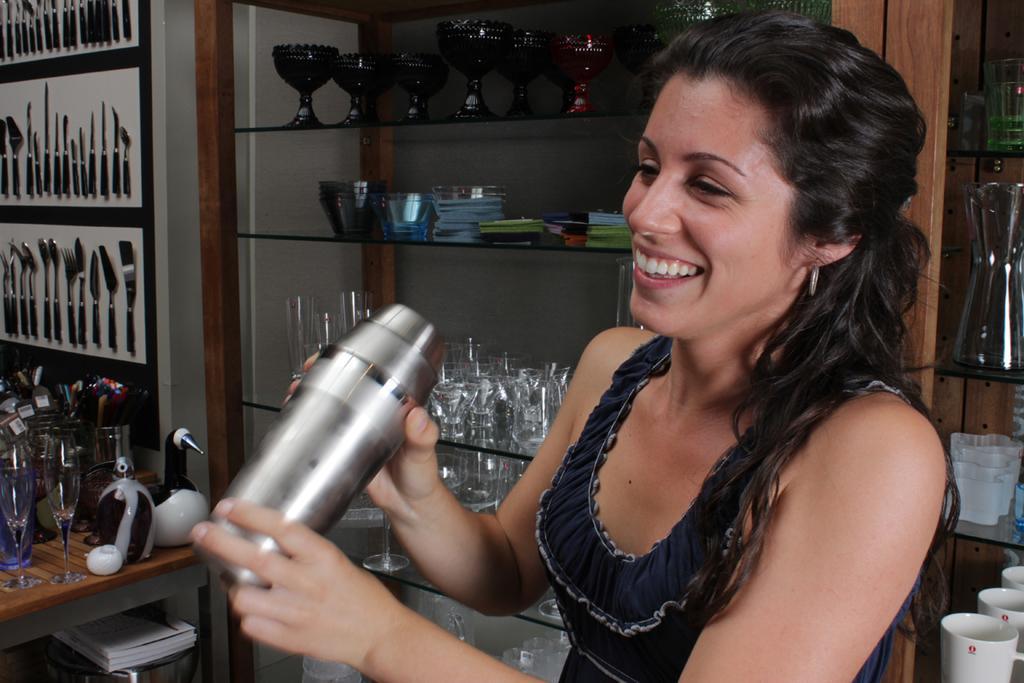Could you give a brief overview of what you see in this image? In the image there is a woman with a shaker and in background there are shelf with glasses and wine glasses on it and there are many bowls in top shelf and over the wall there are many spoons and cutlery set and there is a table in front of the wall. 